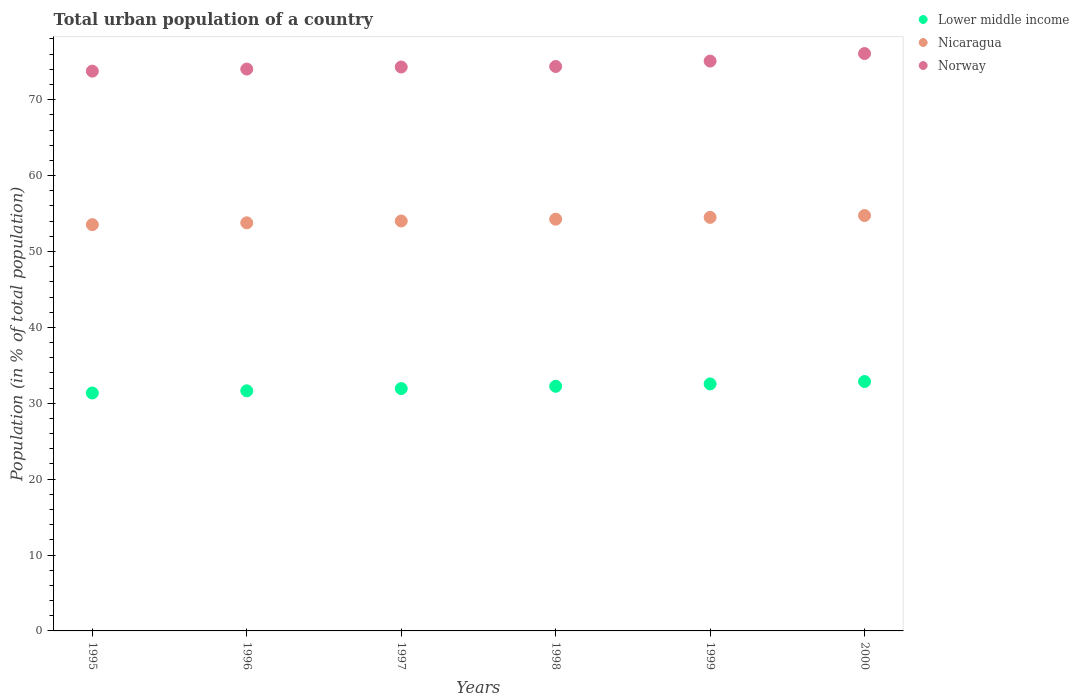How many different coloured dotlines are there?
Give a very brief answer. 3. What is the urban population in Lower middle income in 2000?
Your response must be concise. 32.87. Across all years, what is the maximum urban population in Nicaragua?
Provide a succinct answer. 54.74. Across all years, what is the minimum urban population in Norway?
Ensure brevity in your answer.  73.76. In which year was the urban population in Norway maximum?
Your answer should be compact. 2000. In which year was the urban population in Lower middle income minimum?
Offer a very short reply. 1995. What is the total urban population in Norway in the graph?
Provide a succinct answer. 447.65. What is the difference between the urban population in Norway in 1997 and that in 1998?
Your response must be concise. -0.07. What is the difference between the urban population in Nicaragua in 1998 and the urban population in Norway in 1997?
Your response must be concise. -20.05. What is the average urban population in Norway per year?
Offer a terse response. 74.61. In the year 1999, what is the difference between the urban population in Norway and urban population in Lower middle income?
Provide a succinct answer. 42.54. In how many years, is the urban population in Lower middle income greater than 44 %?
Keep it short and to the point. 0. What is the ratio of the urban population in Nicaragua in 1996 to that in 1999?
Make the answer very short. 0.99. Is the urban population in Norway in 1997 less than that in 1999?
Make the answer very short. Yes. What is the difference between the highest and the second highest urban population in Nicaragua?
Provide a succinct answer. 0.24. What is the difference between the highest and the lowest urban population in Norway?
Your answer should be very brief. 2.32. In how many years, is the urban population in Norway greater than the average urban population in Norway taken over all years?
Your answer should be compact. 2. Is it the case that in every year, the sum of the urban population in Nicaragua and urban population in Norway  is greater than the urban population in Lower middle income?
Offer a terse response. Yes. Is the urban population in Lower middle income strictly less than the urban population in Norway over the years?
Your response must be concise. Yes. How many dotlines are there?
Keep it short and to the point. 3. How many years are there in the graph?
Offer a terse response. 6. What is the difference between two consecutive major ticks on the Y-axis?
Your answer should be compact. 10. Are the values on the major ticks of Y-axis written in scientific E-notation?
Ensure brevity in your answer.  No. Does the graph contain any zero values?
Keep it short and to the point. No. How are the legend labels stacked?
Provide a succinct answer. Vertical. What is the title of the graph?
Ensure brevity in your answer.  Total urban population of a country. Does "Luxembourg" appear as one of the legend labels in the graph?
Offer a very short reply. No. What is the label or title of the Y-axis?
Your response must be concise. Population (in % of total population). What is the Population (in % of total population) in Lower middle income in 1995?
Make the answer very short. 31.35. What is the Population (in % of total population) of Nicaragua in 1995?
Your answer should be very brief. 53.53. What is the Population (in % of total population) of Norway in 1995?
Offer a very short reply. 73.76. What is the Population (in % of total population) in Lower middle income in 1996?
Your response must be concise. 31.64. What is the Population (in % of total population) in Nicaragua in 1996?
Your response must be concise. 53.77. What is the Population (in % of total population) in Norway in 1996?
Provide a succinct answer. 74.04. What is the Population (in % of total population) in Lower middle income in 1997?
Give a very brief answer. 31.94. What is the Population (in % of total population) of Nicaragua in 1997?
Keep it short and to the point. 54.02. What is the Population (in % of total population) of Norway in 1997?
Provide a succinct answer. 74.31. What is the Population (in % of total population) of Lower middle income in 1998?
Make the answer very short. 32.24. What is the Population (in % of total population) in Nicaragua in 1998?
Keep it short and to the point. 54.26. What is the Population (in % of total population) of Norway in 1998?
Provide a succinct answer. 74.38. What is the Population (in % of total population) of Lower middle income in 1999?
Provide a succinct answer. 32.55. What is the Population (in % of total population) of Nicaragua in 1999?
Your answer should be compact. 54.5. What is the Population (in % of total population) in Norway in 1999?
Offer a very short reply. 75.09. What is the Population (in % of total population) of Lower middle income in 2000?
Your response must be concise. 32.87. What is the Population (in % of total population) of Nicaragua in 2000?
Provide a short and direct response. 54.74. What is the Population (in % of total population) in Norway in 2000?
Offer a terse response. 76.08. Across all years, what is the maximum Population (in % of total population) of Lower middle income?
Keep it short and to the point. 32.87. Across all years, what is the maximum Population (in % of total population) of Nicaragua?
Offer a very short reply. 54.74. Across all years, what is the maximum Population (in % of total population) of Norway?
Provide a succinct answer. 76.08. Across all years, what is the minimum Population (in % of total population) in Lower middle income?
Make the answer very short. 31.35. Across all years, what is the minimum Population (in % of total population) of Nicaragua?
Offer a very short reply. 53.53. Across all years, what is the minimum Population (in % of total population) in Norway?
Provide a succinct answer. 73.76. What is the total Population (in % of total population) of Lower middle income in the graph?
Provide a succinct answer. 192.58. What is the total Population (in % of total population) in Nicaragua in the graph?
Provide a short and direct response. 324.81. What is the total Population (in % of total population) in Norway in the graph?
Provide a succinct answer. 447.65. What is the difference between the Population (in % of total population) of Lower middle income in 1995 and that in 1996?
Keep it short and to the point. -0.29. What is the difference between the Population (in % of total population) of Nicaragua in 1995 and that in 1996?
Your answer should be very brief. -0.24. What is the difference between the Population (in % of total population) in Norway in 1995 and that in 1996?
Ensure brevity in your answer.  -0.28. What is the difference between the Population (in % of total population) of Lower middle income in 1995 and that in 1997?
Provide a succinct answer. -0.58. What is the difference between the Population (in % of total population) in Nicaragua in 1995 and that in 1997?
Provide a short and direct response. -0.48. What is the difference between the Population (in % of total population) in Norway in 1995 and that in 1997?
Provide a short and direct response. -0.55. What is the difference between the Population (in % of total population) in Lower middle income in 1995 and that in 1998?
Provide a succinct answer. -0.89. What is the difference between the Population (in % of total population) of Nicaragua in 1995 and that in 1998?
Provide a succinct answer. -0.72. What is the difference between the Population (in % of total population) of Norway in 1995 and that in 1998?
Ensure brevity in your answer.  -0.61. What is the difference between the Population (in % of total population) in Lower middle income in 1995 and that in 1999?
Make the answer very short. -1.2. What is the difference between the Population (in % of total population) of Nicaragua in 1995 and that in 1999?
Offer a terse response. -0.96. What is the difference between the Population (in % of total population) in Norway in 1995 and that in 1999?
Offer a terse response. -1.32. What is the difference between the Population (in % of total population) in Lower middle income in 1995 and that in 2000?
Offer a terse response. -1.51. What is the difference between the Population (in % of total population) of Nicaragua in 1995 and that in 2000?
Your answer should be compact. -1.2. What is the difference between the Population (in % of total population) of Norway in 1995 and that in 2000?
Make the answer very short. -2.32. What is the difference between the Population (in % of total population) of Lower middle income in 1996 and that in 1997?
Offer a very short reply. -0.3. What is the difference between the Population (in % of total population) of Nicaragua in 1996 and that in 1997?
Make the answer very short. -0.24. What is the difference between the Population (in % of total population) of Norway in 1996 and that in 1997?
Provide a succinct answer. -0.27. What is the difference between the Population (in % of total population) of Lower middle income in 1996 and that in 1998?
Ensure brevity in your answer.  -0.6. What is the difference between the Population (in % of total population) in Nicaragua in 1996 and that in 1998?
Ensure brevity in your answer.  -0.48. What is the difference between the Population (in % of total population) of Norway in 1996 and that in 1998?
Your answer should be compact. -0.34. What is the difference between the Population (in % of total population) in Lower middle income in 1996 and that in 1999?
Your answer should be very brief. -0.91. What is the difference between the Population (in % of total population) of Nicaragua in 1996 and that in 1999?
Provide a succinct answer. -0.72. What is the difference between the Population (in % of total population) of Norway in 1996 and that in 1999?
Make the answer very short. -1.05. What is the difference between the Population (in % of total population) of Lower middle income in 1996 and that in 2000?
Provide a succinct answer. -1.23. What is the difference between the Population (in % of total population) in Nicaragua in 1996 and that in 2000?
Your answer should be very brief. -0.96. What is the difference between the Population (in % of total population) in Norway in 1996 and that in 2000?
Ensure brevity in your answer.  -2.04. What is the difference between the Population (in % of total population) in Lower middle income in 1997 and that in 1998?
Make the answer very short. -0.3. What is the difference between the Population (in % of total population) in Nicaragua in 1997 and that in 1998?
Make the answer very short. -0.24. What is the difference between the Population (in % of total population) of Norway in 1997 and that in 1998?
Keep it short and to the point. -0.07. What is the difference between the Population (in % of total population) in Lower middle income in 1997 and that in 1999?
Offer a very short reply. -0.61. What is the difference between the Population (in % of total population) of Nicaragua in 1997 and that in 1999?
Your response must be concise. -0.48. What is the difference between the Population (in % of total population) of Norway in 1997 and that in 1999?
Offer a very short reply. -0.78. What is the difference between the Population (in % of total population) in Lower middle income in 1997 and that in 2000?
Your response must be concise. -0.93. What is the difference between the Population (in % of total population) of Nicaragua in 1997 and that in 2000?
Keep it short and to the point. -0.72. What is the difference between the Population (in % of total population) in Norway in 1997 and that in 2000?
Provide a short and direct response. -1.77. What is the difference between the Population (in % of total population) of Lower middle income in 1998 and that in 1999?
Your answer should be compact. -0.31. What is the difference between the Population (in % of total population) in Nicaragua in 1998 and that in 1999?
Provide a short and direct response. -0.24. What is the difference between the Population (in % of total population) in Norway in 1998 and that in 1999?
Offer a very short reply. -0.71. What is the difference between the Population (in % of total population) of Lower middle income in 1998 and that in 2000?
Your answer should be very brief. -0.63. What is the difference between the Population (in % of total population) of Nicaragua in 1998 and that in 2000?
Give a very brief answer. -0.48. What is the difference between the Population (in % of total population) of Norway in 1998 and that in 2000?
Your response must be concise. -1.71. What is the difference between the Population (in % of total population) in Lower middle income in 1999 and that in 2000?
Offer a very short reply. -0.32. What is the difference between the Population (in % of total population) in Nicaragua in 1999 and that in 2000?
Offer a very short reply. -0.24. What is the difference between the Population (in % of total population) in Norway in 1999 and that in 2000?
Provide a short and direct response. -0.99. What is the difference between the Population (in % of total population) in Lower middle income in 1995 and the Population (in % of total population) in Nicaragua in 1996?
Ensure brevity in your answer.  -22.42. What is the difference between the Population (in % of total population) in Lower middle income in 1995 and the Population (in % of total population) in Norway in 1996?
Provide a succinct answer. -42.69. What is the difference between the Population (in % of total population) of Nicaragua in 1995 and the Population (in % of total population) of Norway in 1996?
Ensure brevity in your answer.  -20.5. What is the difference between the Population (in % of total population) of Lower middle income in 1995 and the Population (in % of total population) of Nicaragua in 1997?
Offer a terse response. -22.67. What is the difference between the Population (in % of total population) in Lower middle income in 1995 and the Population (in % of total population) in Norway in 1997?
Provide a succinct answer. -42.96. What is the difference between the Population (in % of total population) of Nicaragua in 1995 and the Population (in % of total population) of Norway in 1997?
Make the answer very short. -20.77. What is the difference between the Population (in % of total population) in Lower middle income in 1995 and the Population (in % of total population) in Nicaragua in 1998?
Provide a short and direct response. -22.91. What is the difference between the Population (in % of total population) of Lower middle income in 1995 and the Population (in % of total population) of Norway in 1998?
Offer a very short reply. -43.02. What is the difference between the Population (in % of total population) of Nicaragua in 1995 and the Population (in % of total population) of Norway in 1998?
Offer a terse response. -20.84. What is the difference between the Population (in % of total population) of Lower middle income in 1995 and the Population (in % of total population) of Nicaragua in 1999?
Provide a short and direct response. -23.15. What is the difference between the Population (in % of total population) in Lower middle income in 1995 and the Population (in % of total population) in Norway in 1999?
Your response must be concise. -43.74. What is the difference between the Population (in % of total population) in Nicaragua in 1995 and the Population (in % of total population) in Norway in 1999?
Offer a terse response. -21.55. What is the difference between the Population (in % of total population) in Lower middle income in 1995 and the Population (in % of total population) in Nicaragua in 2000?
Ensure brevity in your answer.  -23.39. What is the difference between the Population (in % of total population) of Lower middle income in 1995 and the Population (in % of total population) of Norway in 2000?
Offer a very short reply. -44.73. What is the difference between the Population (in % of total population) in Nicaragua in 1995 and the Population (in % of total population) in Norway in 2000?
Your response must be concise. -22.55. What is the difference between the Population (in % of total population) in Lower middle income in 1996 and the Population (in % of total population) in Nicaragua in 1997?
Your answer should be compact. -22.38. What is the difference between the Population (in % of total population) in Lower middle income in 1996 and the Population (in % of total population) in Norway in 1997?
Your answer should be compact. -42.67. What is the difference between the Population (in % of total population) of Nicaragua in 1996 and the Population (in % of total population) of Norway in 1997?
Keep it short and to the point. -20.53. What is the difference between the Population (in % of total population) of Lower middle income in 1996 and the Population (in % of total population) of Nicaragua in 1998?
Keep it short and to the point. -22.62. What is the difference between the Population (in % of total population) in Lower middle income in 1996 and the Population (in % of total population) in Norway in 1998?
Keep it short and to the point. -42.74. What is the difference between the Population (in % of total population) in Nicaragua in 1996 and the Population (in % of total population) in Norway in 1998?
Your response must be concise. -20.6. What is the difference between the Population (in % of total population) of Lower middle income in 1996 and the Population (in % of total population) of Nicaragua in 1999?
Provide a short and direct response. -22.86. What is the difference between the Population (in % of total population) of Lower middle income in 1996 and the Population (in % of total population) of Norway in 1999?
Your response must be concise. -43.45. What is the difference between the Population (in % of total population) in Nicaragua in 1996 and the Population (in % of total population) in Norway in 1999?
Your response must be concise. -21.31. What is the difference between the Population (in % of total population) of Lower middle income in 1996 and the Population (in % of total population) of Nicaragua in 2000?
Offer a very short reply. -23.1. What is the difference between the Population (in % of total population) of Lower middle income in 1996 and the Population (in % of total population) of Norway in 2000?
Your answer should be very brief. -44.44. What is the difference between the Population (in % of total population) of Nicaragua in 1996 and the Population (in % of total population) of Norway in 2000?
Provide a short and direct response. -22.31. What is the difference between the Population (in % of total population) in Lower middle income in 1997 and the Population (in % of total population) in Nicaragua in 1998?
Provide a succinct answer. -22.32. What is the difference between the Population (in % of total population) of Lower middle income in 1997 and the Population (in % of total population) of Norway in 1998?
Your response must be concise. -42.44. What is the difference between the Population (in % of total population) in Nicaragua in 1997 and the Population (in % of total population) in Norway in 1998?
Keep it short and to the point. -20.36. What is the difference between the Population (in % of total population) in Lower middle income in 1997 and the Population (in % of total population) in Nicaragua in 1999?
Your answer should be very brief. -22.56. What is the difference between the Population (in % of total population) of Lower middle income in 1997 and the Population (in % of total population) of Norway in 1999?
Make the answer very short. -43.15. What is the difference between the Population (in % of total population) of Nicaragua in 1997 and the Population (in % of total population) of Norway in 1999?
Offer a terse response. -21.07. What is the difference between the Population (in % of total population) in Lower middle income in 1997 and the Population (in % of total population) in Nicaragua in 2000?
Keep it short and to the point. -22.8. What is the difference between the Population (in % of total population) of Lower middle income in 1997 and the Population (in % of total population) of Norway in 2000?
Give a very brief answer. -44.15. What is the difference between the Population (in % of total population) of Nicaragua in 1997 and the Population (in % of total population) of Norway in 2000?
Provide a short and direct response. -22.07. What is the difference between the Population (in % of total population) in Lower middle income in 1998 and the Population (in % of total population) in Nicaragua in 1999?
Provide a succinct answer. -22.26. What is the difference between the Population (in % of total population) of Lower middle income in 1998 and the Population (in % of total population) of Norway in 1999?
Your response must be concise. -42.85. What is the difference between the Population (in % of total population) of Nicaragua in 1998 and the Population (in % of total population) of Norway in 1999?
Offer a very short reply. -20.83. What is the difference between the Population (in % of total population) in Lower middle income in 1998 and the Population (in % of total population) in Nicaragua in 2000?
Make the answer very short. -22.5. What is the difference between the Population (in % of total population) in Lower middle income in 1998 and the Population (in % of total population) in Norway in 2000?
Keep it short and to the point. -43.84. What is the difference between the Population (in % of total population) of Nicaragua in 1998 and the Population (in % of total population) of Norway in 2000?
Provide a succinct answer. -21.82. What is the difference between the Population (in % of total population) of Lower middle income in 1999 and the Population (in % of total population) of Nicaragua in 2000?
Keep it short and to the point. -22.19. What is the difference between the Population (in % of total population) in Lower middle income in 1999 and the Population (in % of total population) in Norway in 2000?
Provide a short and direct response. -43.53. What is the difference between the Population (in % of total population) in Nicaragua in 1999 and the Population (in % of total population) in Norway in 2000?
Keep it short and to the point. -21.59. What is the average Population (in % of total population) of Lower middle income per year?
Ensure brevity in your answer.  32.1. What is the average Population (in % of total population) in Nicaragua per year?
Your answer should be compact. 54.14. What is the average Population (in % of total population) of Norway per year?
Give a very brief answer. 74.61. In the year 1995, what is the difference between the Population (in % of total population) in Lower middle income and Population (in % of total population) in Nicaragua?
Your answer should be very brief. -22.18. In the year 1995, what is the difference between the Population (in % of total population) in Lower middle income and Population (in % of total population) in Norway?
Your response must be concise. -42.41. In the year 1995, what is the difference between the Population (in % of total population) of Nicaragua and Population (in % of total population) of Norway?
Your answer should be compact. -20.23. In the year 1996, what is the difference between the Population (in % of total population) of Lower middle income and Population (in % of total population) of Nicaragua?
Your response must be concise. -22.14. In the year 1996, what is the difference between the Population (in % of total population) of Lower middle income and Population (in % of total population) of Norway?
Your answer should be very brief. -42.4. In the year 1996, what is the difference between the Population (in % of total population) of Nicaragua and Population (in % of total population) of Norway?
Make the answer very short. -20.26. In the year 1997, what is the difference between the Population (in % of total population) of Lower middle income and Population (in % of total population) of Nicaragua?
Offer a terse response. -22.08. In the year 1997, what is the difference between the Population (in % of total population) in Lower middle income and Population (in % of total population) in Norway?
Ensure brevity in your answer.  -42.37. In the year 1997, what is the difference between the Population (in % of total population) of Nicaragua and Population (in % of total population) of Norway?
Provide a short and direct response. -20.29. In the year 1998, what is the difference between the Population (in % of total population) in Lower middle income and Population (in % of total population) in Nicaragua?
Provide a succinct answer. -22.02. In the year 1998, what is the difference between the Population (in % of total population) of Lower middle income and Population (in % of total population) of Norway?
Make the answer very short. -42.14. In the year 1998, what is the difference between the Population (in % of total population) in Nicaragua and Population (in % of total population) in Norway?
Your answer should be compact. -20.12. In the year 1999, what is the difference between the Population (in % of total population) in Lower middle income and Population (in % of total population) in Nicaragua?
Your answer should be compact. -21.95. In the year 1999, what is the difference between the Population (in % of total population) in Lower middle income and Population (in % of total population) in Norway?
Give a very brief answer. -42.54. In the year 1999, what is the difference between the Population (in % of total population) in Nicaragua and Population (in % of total population) in Norway?
Keep it short and to the point. -20.59. In the year 2000, what is the difference between the Population (in % of total population) of Lower middle income and Population (in % of total population) of Nicaragua?
Give a very brief answer. -21.87. In the year 2000, what is the difference between the Population (in % of total population) of Lower middle income and Population (in % of total population) of Norway?
Keep it short and to the point. -43.22. In the year 2000, what is the difference between the Population (in % of total population) in Nicaragua and Population (in % of total population) in Norway?
Your response must be concise. -21.34. What is the ratio of the Population (in % of total population) of Lower middle income in 1995 to that in 1996?
Your answer should be compact. 0.99. What is the ratio of the Population (in % of total population) of Nicaragua in 1995 to that in 1996?
Keep it short and to the point. 1. What is the ratio of the Population (in % of total population) of Lower middle income in 1995 to that in 1997?
Give a very brief answer. 0.98. What is the ratio of the Population (in % of total population) in Nicaragua in 1995 to that in 1997?
Keep it short and to the point. 0.99. What is the ratio of the Population (in % of total population) in Lower middle income in 1995 to that in 1998?
Your answer should be compact. 0.97. What is the ratio of the Population (in % of total population) of Nicaragua in 1995 to that in 1998?
Provide a short and direct response. 0.99. What is the ratio of the Population (in % of total population) of Lower middle income in 1995 to that in 1999?
Give a very brief answer. 0.96. What is the ratio of the Population (in % of total population) of Nicaragua in 1995 to that in 1999?
Offer a very short reply. 0.98. What is the ratio of the Population (in % of total population) of Norway in 1995 to that in 1999?
Provide a short and direct response. 0.98. What is the ratio of the Population (in % of total population) in Lower middle income in 1995 to that in 2000?
Keep it short and to the point. 0.95. What is the ratio of the Population (in % of total population) of Norway in 1995 to that in 2000?
Your response must be concise. 0.97. What is the ratio of the Population (in % of total population) of Lower middle income in 1996 to that in 1998?
Keep it short and to the point. 0.98. What is the ratio of the Population (in % of total population) in Lower middle income in 1996 to that in 1999?
Your answer should be very brief. 0.97. What is the ratio of the Population (in % of total population) of Norway in 1996 to that in 1999?
Offer a very short reply. 0.99. What is the ratio of the Population (in % of total population) in Lower middle income in 1996 to that in 2000?
Offer a very short reply. 0.96. What is the ratio of the Population (in % of total population) in Nicaragua in 1996 to that in 2000?
Give a very brief answer. 0.98. What is the ratio of the Population (in % of total population) in Norway in 1996 to that in 2000?
Keep it short and to the point. 0.97. What is the ratio of the Population (in % of total population) of Lower middle income in 1997 to that in 1998?
Keep it short and to the point. 0.99. What is the ratio of the Population (in % of total population) in Nicaragua in 1997 to that in 1998?
Your response must be concise. 1. What is the ratio of the Population (in % of total population) of Lower middle income in 1997 to that in 1999?
Your answer should be compact. 0.98. What is the ratio of the Population (in % of total population) in Nicaragua in 1997 to that in 1999?
Your answer should be compact. 0.99. What is the ratio of the Population (in % of total population) of Lower middle income in 1997 to that in 2000?
Give a very brief answer. 0.97. What is the ratio of the Population (in % of total population) in Nicaragua in 1997 to that in 2000?
Provide a succinct answer. 0.99. What is the ratio of the Population (in % of total population) of Norway in 1997 to that in 2000?
Provide a succinct answer. 0.98. What is the ratio of the Population (in % of total population) of Lower middle income in 1998 to that in 2000?
Your response must be concise. 0.98. What is the ratio of the Population (in % of total population) in Norway in 1998 to that in 2000?
Your answer should be compact. 0.98. What is the ratio of the Population (in % of total population) of Lower middle income in 1999 to that in 2000?
Make the answer very short. 0.99. What is the ratio of the Population (in % of total population) in Norway in 1999 to that in 2000?
Give a very brief answer. 0.99. What is the difference between the highest and the second highest Population (in % of total population) of Lower middle income?
Offer a very short reply. 0.32. What is the difference between the highest and the second highest Population (in % of total population) in Nicaragua?
Your answer should be compact. 0.24. What is the difference between the highest and the lowest Population (in % of total population) in Lower middle income?
Make the answer very short. 1.51. What is the difference between the highest and the lowest Population (in % of total population) of Nicaragua?
Provide a succinct answer. 1.2. What is the difference between the highest and the lowest Population (in % of total population) in Norway?
Ensure brevity in your answer.  2.32. 